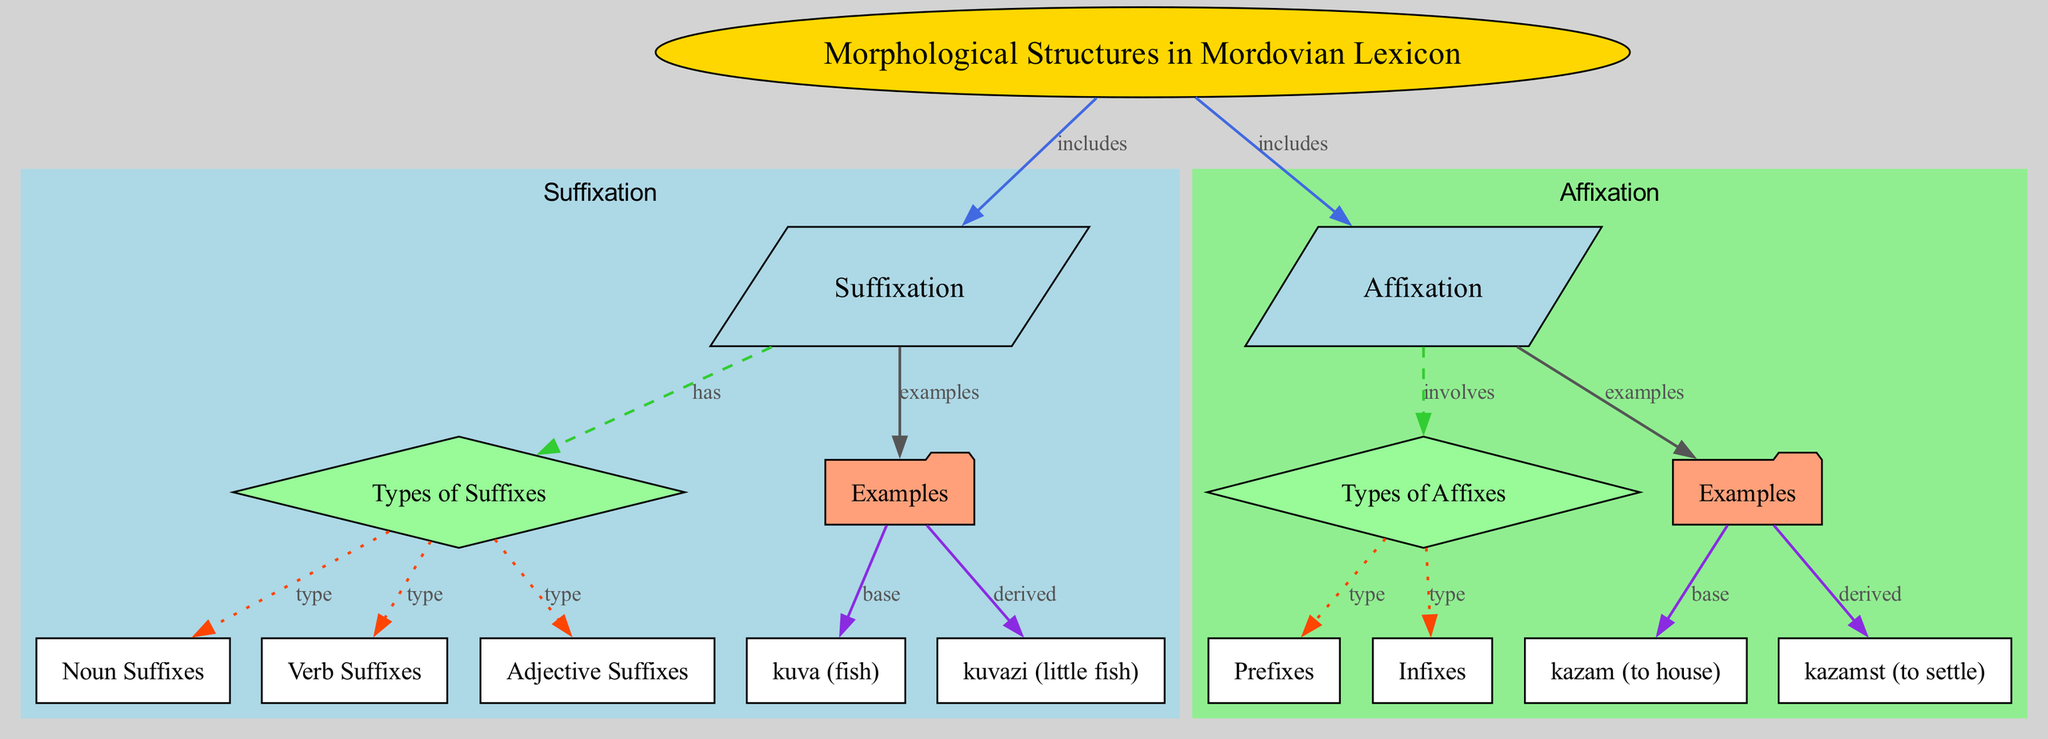what is the main topic of the diagram? The title of the diagram indicates that the main topic is "Morphological Structures in Mordovian Lexicon." This serves as the root of the entire structure, branching into different morphological processes.
Answer: Morphological Structures in Mordovian Lexicon how many suffix types are shown in the diagram? The diagram contains three suffix types: noun suffixes, verb suffixes, and adjective suffixes. These types are directly linked to the "Types of Suffixes" node, which indicates that there are three specific types.
Answer: three which examples are provided under suffixation? The examples under suffixation are "kuva" as the base and "kuvazi" as the derived form. These are connected to the "Examples" node under the suffixation section, showing their relationship.
Answer: kuva, kuvazi what are the two types of affixes mentioned? The two types of affixes mentioned are prefixes and infixes. These types are linked to the "Types of Affixes" node, representing the different morphological elements involved in affixation.
Answer: prefixes, infixes which example is derived from "kazam"? The derived example from "kazam" is "kazamst." The diagram indicates that "kazamst" is formed from the base "kazam," showing the affixation process at work.
Answer: kazamst how does suffixation relate to morphological structures? Suffixation is one of the main components included under the broader category of morphological structures. This relationship is established by the "includes" edge connecting the "Morphological Structures in Mordovian Lexicon" to the "Suffixation" node, indicating its significance in the overall structure.
Answer: includes what is the shape of the node representing suffix examples? The shape of the node representing suffix examples is a folder. This distinctive shape often signifies examples or categories in diagrams, helping to differentiate it from other types of nodes.
Answer: folder how many nodes are directly connected to "affixation"? There are three nodes directly connected to "affixation": "affixTypes," "affixExamples," and "affixExamples." This indicates a structured relationship focused on the types and examples of affixation in the diagram.
Answer: three what color is used for the "Suffixation" cluster? The "Suffixation" cluster is colored light blue. This visual differentiation helps viewers easily identify sections of the diagram and emphasizes the component of suffixation within the overall morphological structures.
Answer: light blue 